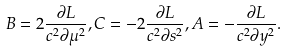Convert formula to latex. <formula><loc_0><loc_0><loc_500><loc_500>B = 2 \frac { \partial L } { c ^ { 2 } \partial \mu ^ { 2 } } , C = - 2 \frac { \partial L } { c ^ { 2 } \partial s ^ { 2 } } , A = - \frac { \partial L } { c ^ { 2 } \partial y ^ { 2 } } .</formula> 